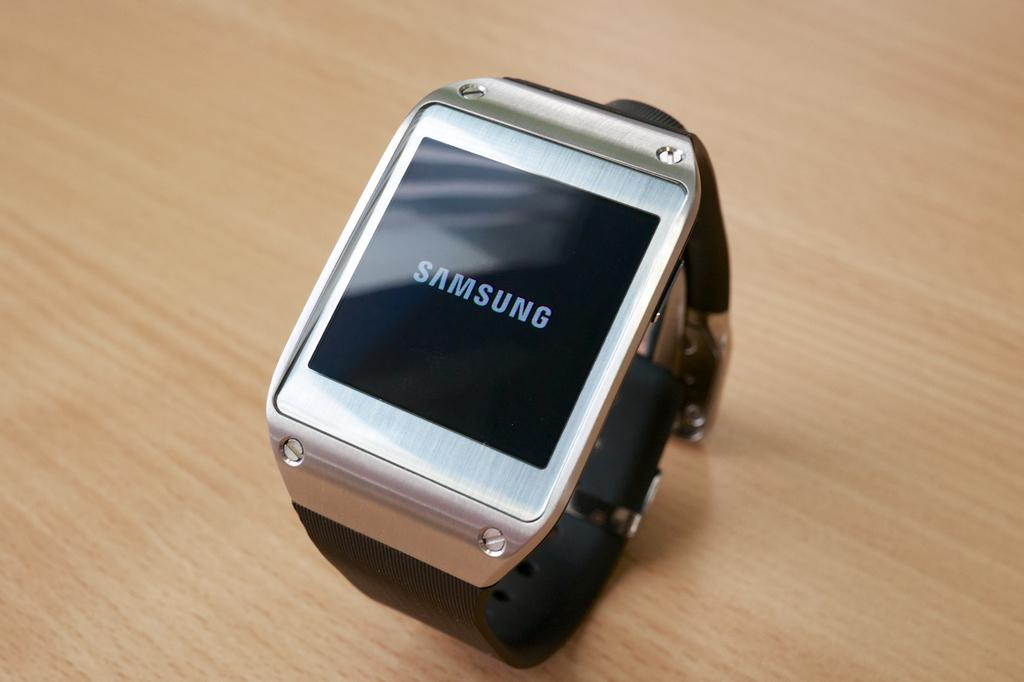<image>
Give a short and clear explanation of the subsequent image. a Samsung watch with wifi capibilities. 